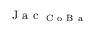Convert formula to latex. <formula><loc_0><loc_0><loc_500><loc_500>J a c _ { C o B a }</formula> 